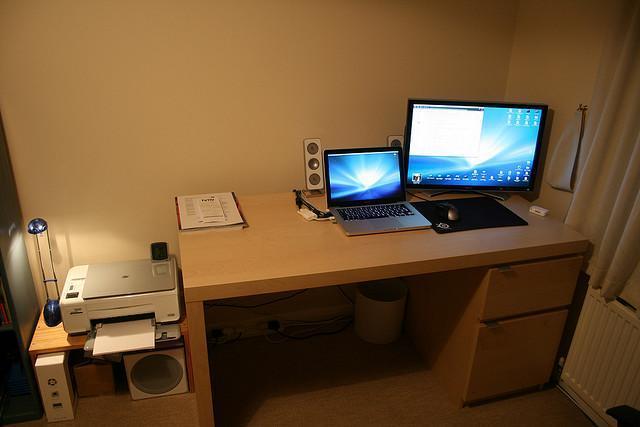How many white horses are pulling the carriage?
Give a very brief answer. 0. 